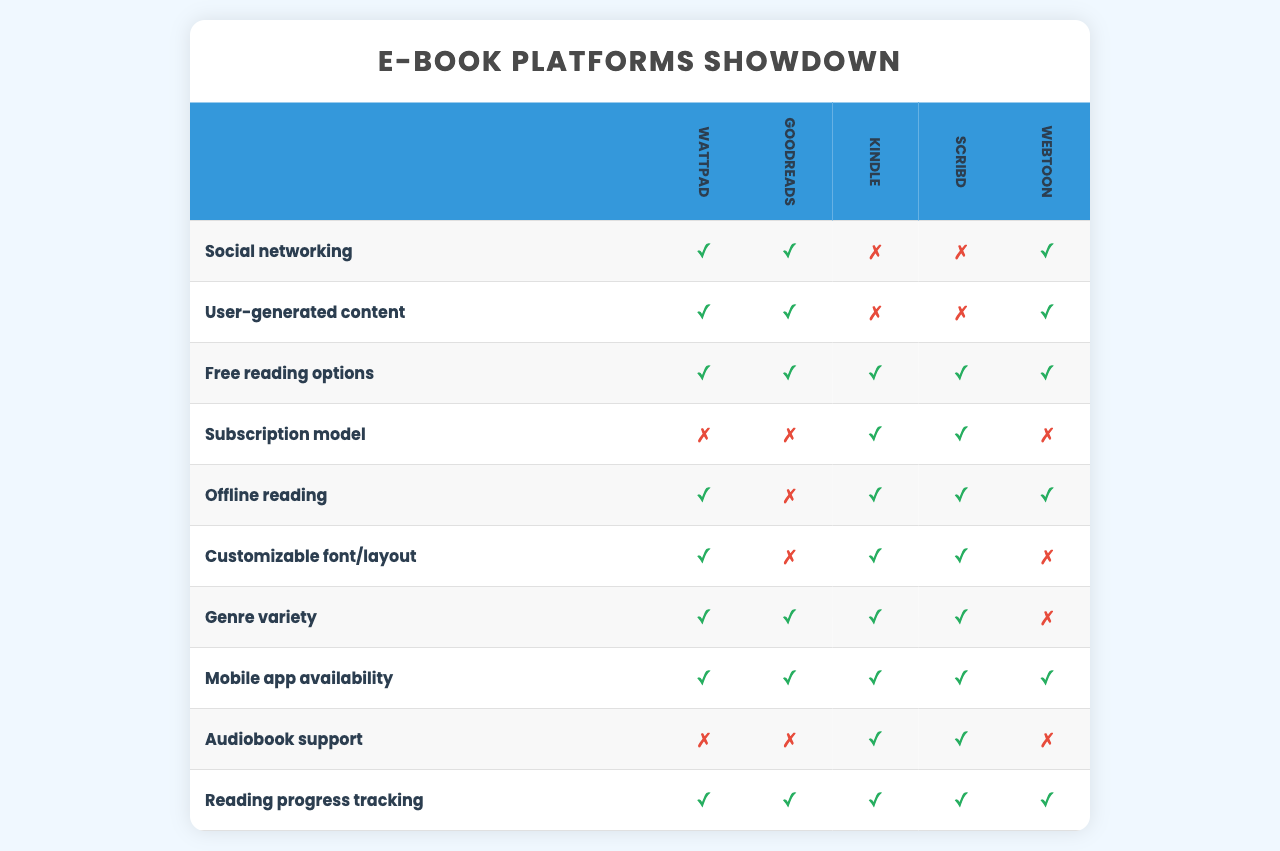What platforms support social networking? Looking at the 'Social networking' feature row, the platforms that have a checkmark (✓) are Wattpad, Goodreads, and Webtoon. Therefore, these three platforms support social networking.
Answer: Wattpad, Goodreads, Webtoon Which platform has the most features available? By counting the checkmarks for each platform, both Kindle and Scribd have 7 features available, which is the highest among the platforms listed.
Answer: Kindle, Scribd Is there a platform that offers offline reading and customizable font/layout? By checking the corresponding columns for the features 'Offline reading' and 'Customizable font/layout', both Kindle and Scribd have checkmarks (✓) for these features.
Answer: Yes How many platforms offer free reading options? By looking at the 'Free reading options' feature, I see that Wattpad, Goodreads, Kindle, Scribd, and Webtoon all have checkmarks (✓). This gives us a total of 5 platforms offering free reading options.
Answer: 5 Does any platform provide audiobook support? The table shows that the only platforms that have a checkmark (✓) for 'Audiobook support' are Kindle and Scribd.
Answer: Yes Which feature is only available on Wattpad? In the row for 'User-generated content', Wattpad is the only platform with a checkmark (✓), indicating that this feature is unique to it.
Answer: User-generated content What is the total number of features supported by Goodreads? By counting the checkmarks (✓) for Goodreads, I find that it supports 5 features.
Answer: 5 Which two platforms have the same features related to genre variety, mobile app availability, and reading progress tracking? By analyzing the rows for these features, both Kindle and Scribd have checkmarks (✓) in all these categories. This shows that they offer the same features related to these specific areas.
Answer: Kindle, Scribd How does the subscription model differ between platforms? The 'Subscription model' row indicates that only Kindle and Scribd have a checkmark (✓), implying that they utilize a subscription model, while the others do not.
Answer: Two platforms: Kindle, Scribd Are there any platforms that support both offline reading and audiobook support? Checking the relevant features, only Kindle supports both 'Offline reading' and 'Audiobook support' with checkmarks (✓).
Answer: Yes, Kindle only 